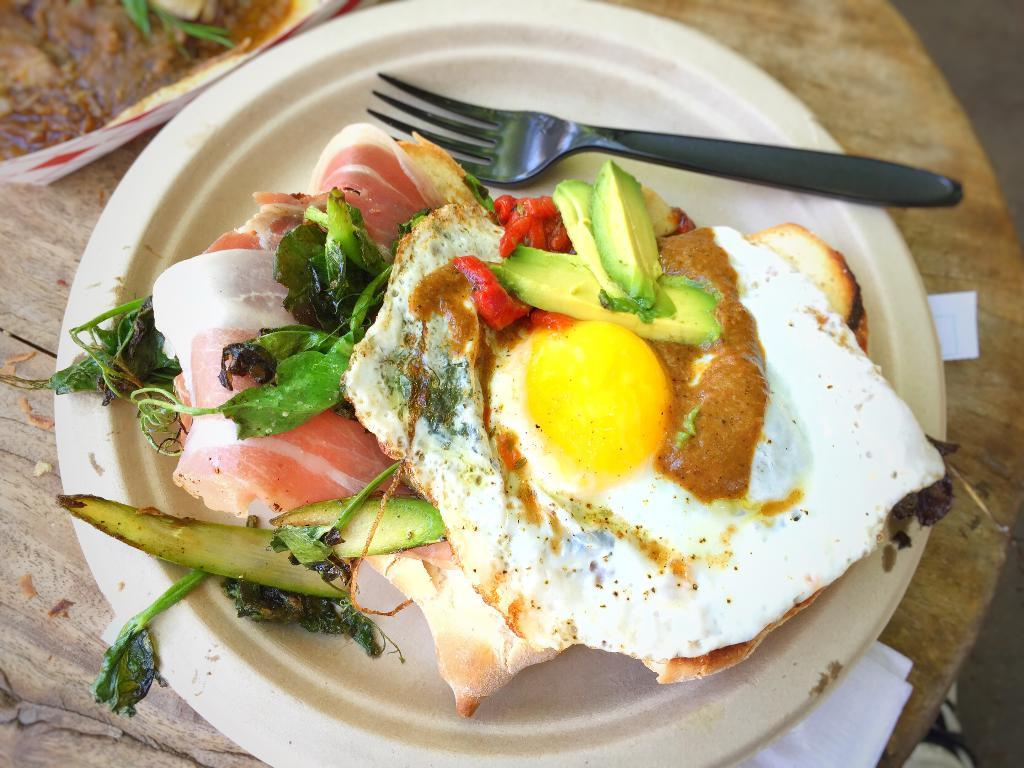What is on the plate in the image? There is food on the plate in the image. What utensil is present in the image? There is a fork in the image. Where are the plate and fork located? The objects are on a table. What type of linen is draped over the plate in the image? There is no linen present in the image; it only features a plate with food and a fork. How many calculations can be seen being performed on the calculator in the image? There is no calculator present in the image. 